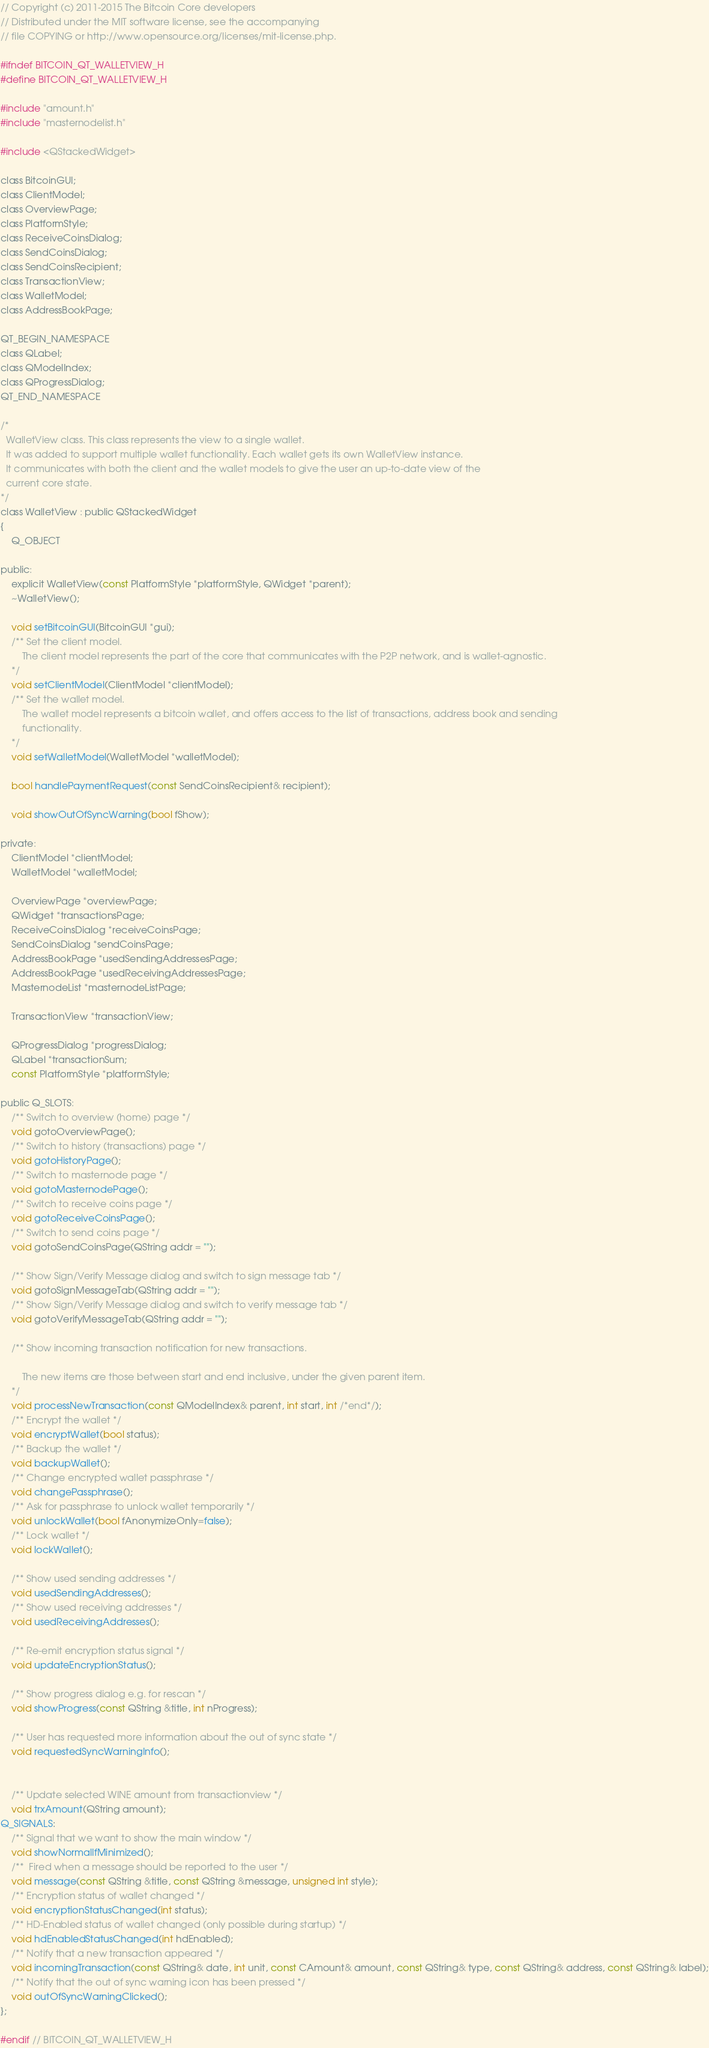<code> <loc_0><loc_0><loc_500><loc_500><_C_>// Copyright (c) 2011-2015 The Bitcoin Core developers
// Distributed under the MIT software license, see the accompanying
// file COPYING or http://www.opensource.org/licenses/mit-license.php.

#ifndef BITCOIN_QT_WALLETVIEW_H
#define BITCOIN_QT_WALLETVIEW_H

#include "amount.h"
#include "masternodelist.h"

#include <QStackedWidget>

class BitcoinGUI;
class ClientModel;
class OverviewPage;
class PlatformStyle;
class ReceiveCoinsDialog;
class SendCoinsDialog;
class SendCoinsRecipient;
class TransactionView;
class WalletModel;
class AddressBookPage;

QT_BEGIN_NAMESPACE
class QLabel;
class QModelIndex;
class QProgressDialog;
QT_END_NAMESPACE

/*
  WalletView class. This class represents the view to a single wallet.
  It was added to support multiple wallet functionality. Each wallet gets its own WalletView instance.
  It communicates with both the client and the wallet models to give the user an up-to-date view of the
  current core state.
*/
class WalletView : public QStackedWidget
{
    Q_OBJECT

public:
    explicit WalletView(const PlatformStyle *platformStyle, QWidget *parent);
    ~WalletView();

    void setBitcoinGUI(BitcoinGUI *gui);
    /** Set the client model.
        The client model represents the part of the core that communicates with the P2P network, and is wallet-agnostic.
    */
    void setClientModel(ClientModel *clientModel);
    /** Set the wallet model.
        The wallet model represents a bitcoin wallet, and offers access to the list of transactions, address book and sending
        functionality.
    */
    void setWalletModel(WalletModel *walletModel);

    bool handlePaymentRequest(const SendCoinsRecipient& recipient);

    void showOutOfSyncWarning(bool fShow);

private:
    ClientModel *clientModel;
    WalletModel *walletModel;

    OverviewPage *overviewPage;
    QWidget *transactionsPage;
    ReceiveCoinsDialog *receiveCoinsPage;
    SendCoinsDialog *sendCoinsPage;
    AddressBookPage *usedSendingAddressesPage;
    AddressBookPage *usedReceivingAddressesPage;
    MasternodeList *masternodeListPage;

    TransactionView *transactionView;

    QProgressDialog *progressDialog;
    QLabel *transactionSum;
    const PlatformStyle *platformStyle;

public Q_SLOTS:
    /** Switch to overview (home) page */
    void gotoOverviewPage();
    /** Switch to history (transactions) page */
    void gotoHistoryPage();
    /** Switch to masternode page */
    void gotoMasternodePage();
    /** Switch to receive coins page */
    void gotoReceiveCoinsPage();
    /** Switch to send coins page */
    void gotoSendCoinsPage(QString addr = "");

    /** Show Sign/Verify Message dialog and switch to sign message tab */
    void gotoSignMessageTab(QString addr = "");
    /** Show Sign/Verify Message dialog and switch to verify message tab */
    void gotoVerifyMessageTab(QString addr = "");

    /** Show incoming transaction notification for new transactions.

        The new items are those between start and end inclusive, under the given parent item.
    */
    void processNewTransaction(const QModelIndex& parent, int start, int /*end*/);
    /** Encrypt the wallet */
    void encryptWallet(bool status);
    /** Backup the wallet */
    void backupWallet();
    /** Change encrypted wallet passphrase */
    void changePassphrase();
    /** Ask for passphrase to unlock wallet temporarily */
    void unlockWallet(bool fAnonymizeOnly=false);
    /** Lock wallet */
    void lockWallet();

    /** Show used sending addresses */
    void usedSendingAddresses();
    /** Show used receiving addresses */
    void usedReceivingAddresses();

    /** Re-emit encryption status signal */
    void updateEncryptionStatus();

    /** Show progress dialog e.g. for rescan */
    void showProgress(const QString &title, int nProgress);

    /** User has requested more information about the out of sync state */
    void requestedSyncWarningInfo();


    /** Update selected WINE amount from transactionview */
    void trxAmount(QString amount);
Q_SIGNALS:
    /** Signal that we want to show the main window */
    void showNormalIfMinimized();
    /**  Fired when a message should be reported to the user */
    void message(const QString &title, const QString &message, unsigned int style);
    /** Encryption status of wallet changed */
    void encryptionStatusChanged(int status);
    /** HD-Enabled status of wallet changed (only possible during startup) */
    void hdEnabledStatusChanged(int hdEnabled);
    /** Notify that a new transaction appeared */
    void incomingTransaction(const QString& date, int unit, const CAmount& amount, const QString& type, const QString& address, const QString& label);
    /** Notify that the out of sync warning icon has been pressed */
    void outOfSyncWarningClicked();
};

#endif // BITCOIN_QT_WALLETVIEW_H
</code> 